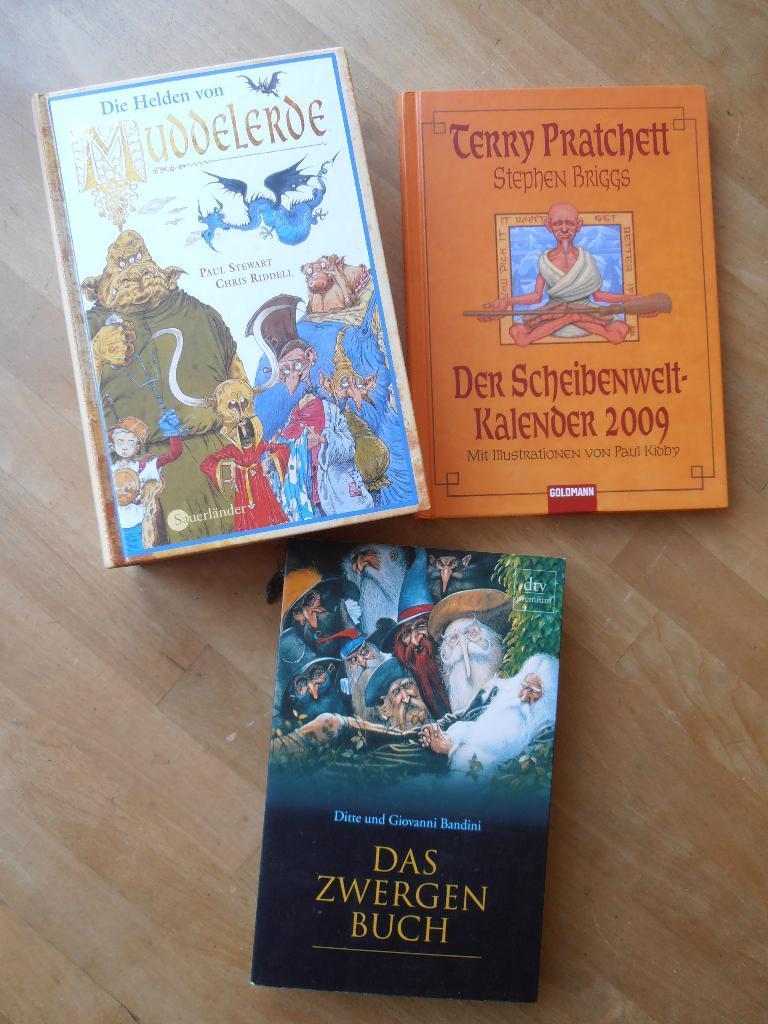Describe this image in one or two sentences. This picture contains three books. The book in orange color with some text written on it is on the table. Beside that, the book in black and green color is placed on the table. The book in white color with cartoons is on the table. 